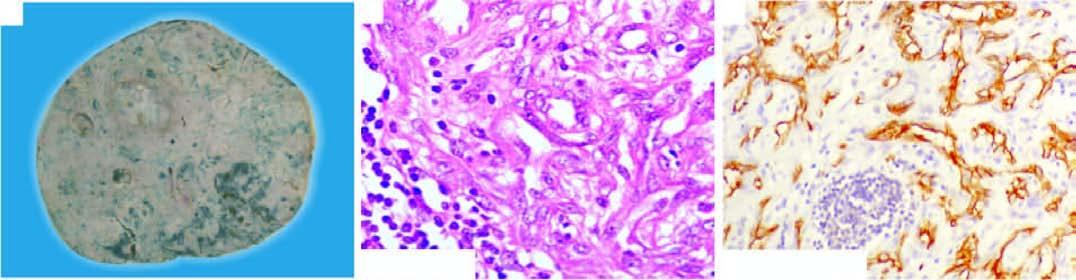does platelet aggregation show proliferation of moderately pleomorphic anaplastic cells?
Answer the question using a single word or phrase. No 